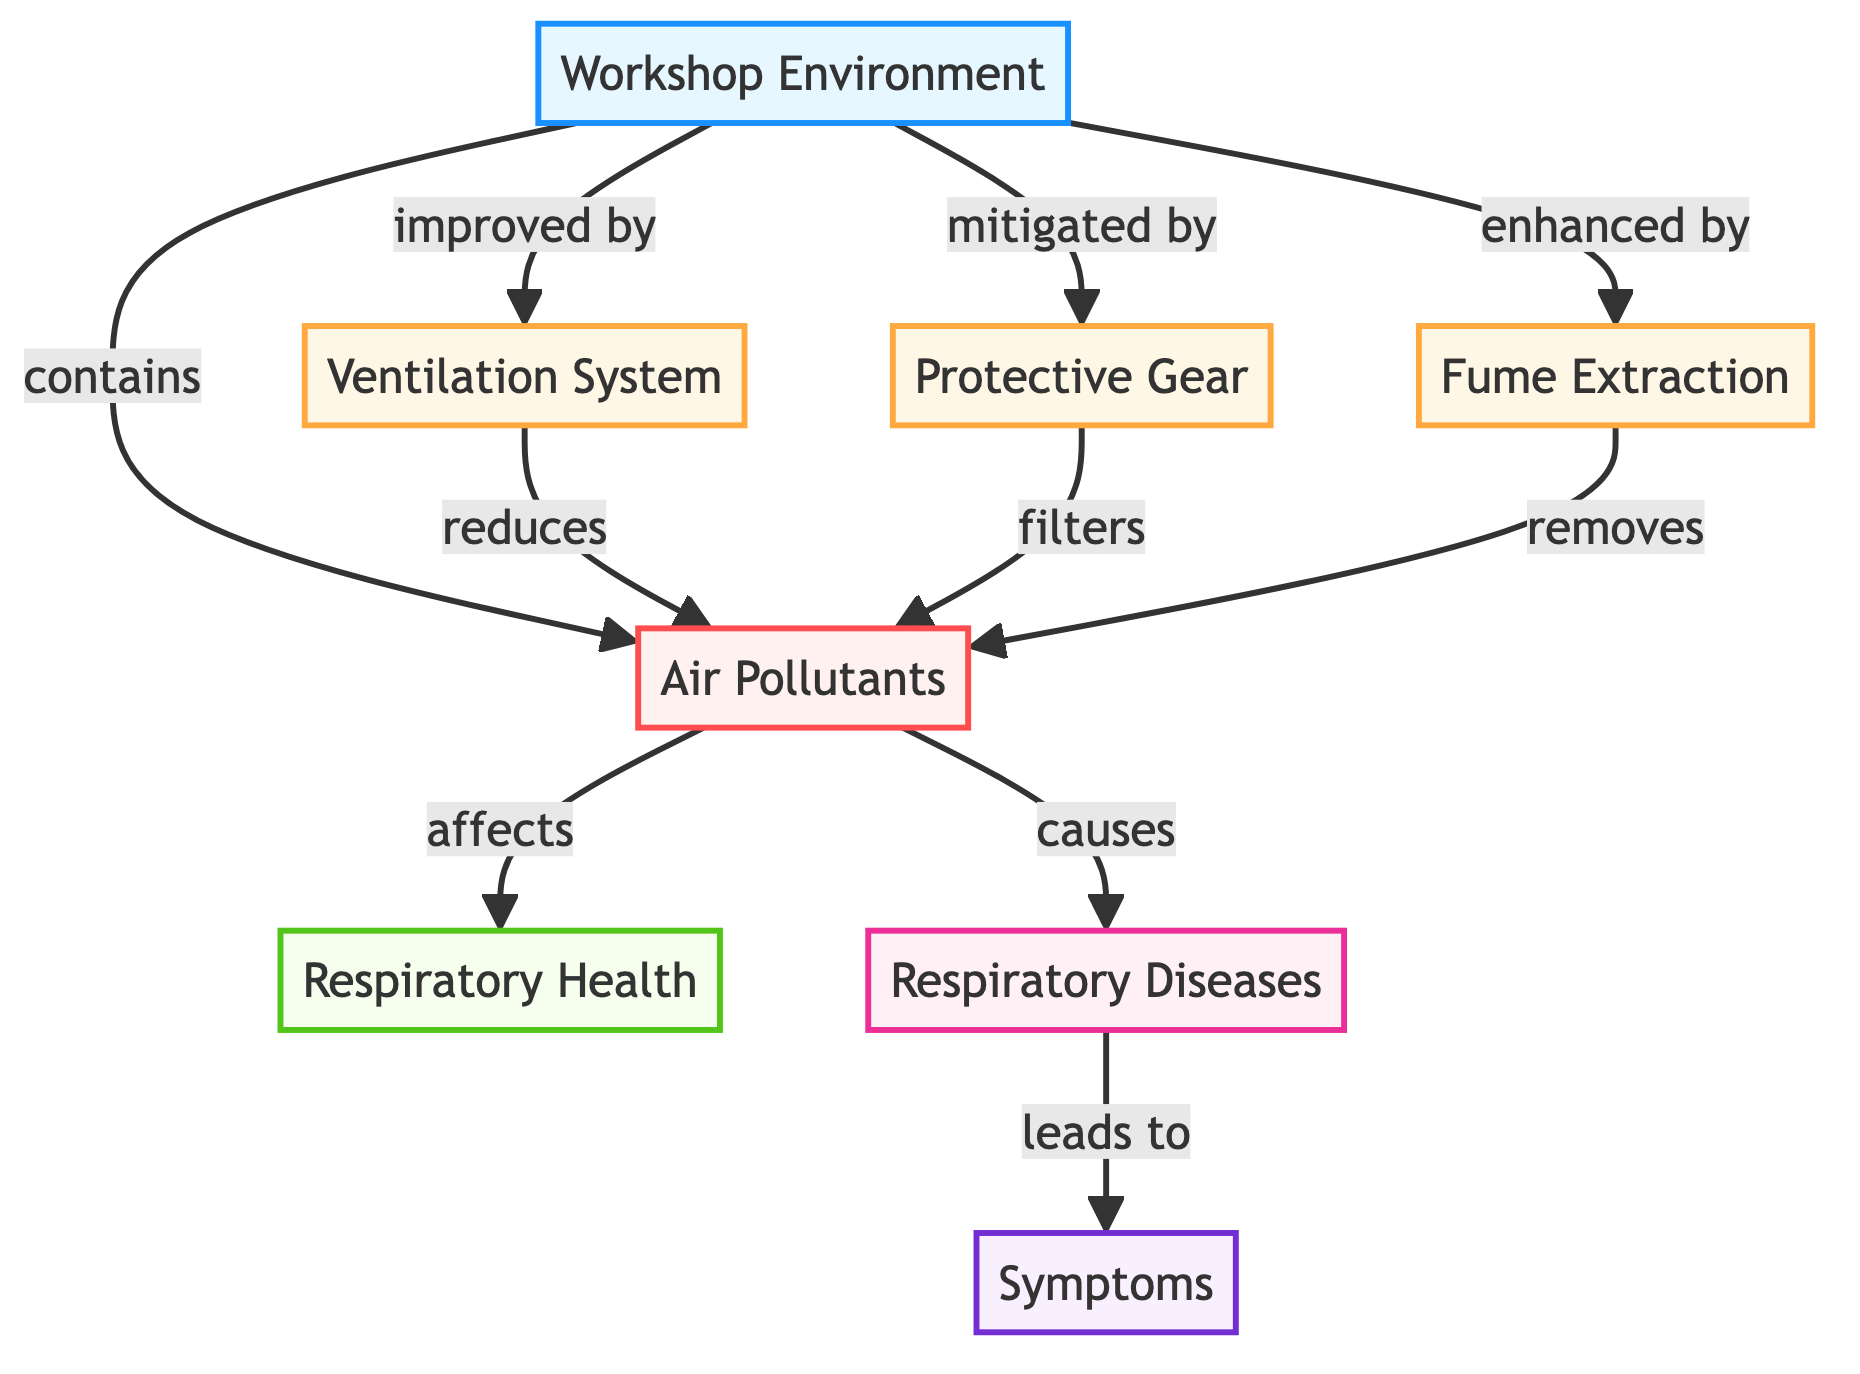What is the main focus of the diagram? The diagram focuses on the relationship between air quality and respiratory health in car restoration workshops. It illustrates how pollutants in the workshop environment affect respiratory health and how various controls can mitigate these effects.
Answer: Air quality and respiratory health What do pollutants affect according to the diagram? The diagram indicates that pollutants affect respiratory health directly. By tracing the connection from pollutants to respiratory health, it shows a direct impact on the affected health status.
Answer: Respiratory health How many types of controls are identified in the diagram? The diagram shows three types of controls aimed at mitigating pollutants: ventilation system, protective gear, and fume extraction. Counting these nodes indicates the number of control types.
Answer: Three Which control method reduces pollutants? The diagram specifies that the ventilation system reduces pollutants in the workshop environment. By following the arrows from the ventilation node, this impact is illustrated clearly.
Answer: Ventilation system What are the symptoms associated with respiratory diseases? The diagram shows that respiratory diseases lead to symptoms. To determine the implications, one needs to follow the path from respiratory diseases to symptoms within the structure.
Answer: Symptoms How does protective gear interact with pollutants? Protective gear is shown in the diagram to filter pollutants, which means it provides a protective function for individuals in the workshop environment. By tracing the arrows from protective gear, this interaction is clear.
Answer: Filters What ultimately leads to symptoms in the diagram? The diagram indicates that respiratory diseases lead to symptoms, making it clear that symptoms arise as a consequence of respiratory diseases. Following the flow of this relationship shows this outcome.
Answer: Respiratory diseases What enhances the workshop environment according to the diagram? The diagram points to fume extraction as a method that enhances the workshop environment by removing pollutants. This enhancement is detailed in the relationships illustrated in the diagram.
Answer: Fume extraction How do air pollutants influence respiratory diseases? The diagram shows a direct link where pollutants cause respiratory diseases. By examining the flow from pollutants to respiratory diseases, one can see this causal effect clearly outlined in the diagram.
Answer: Causes 